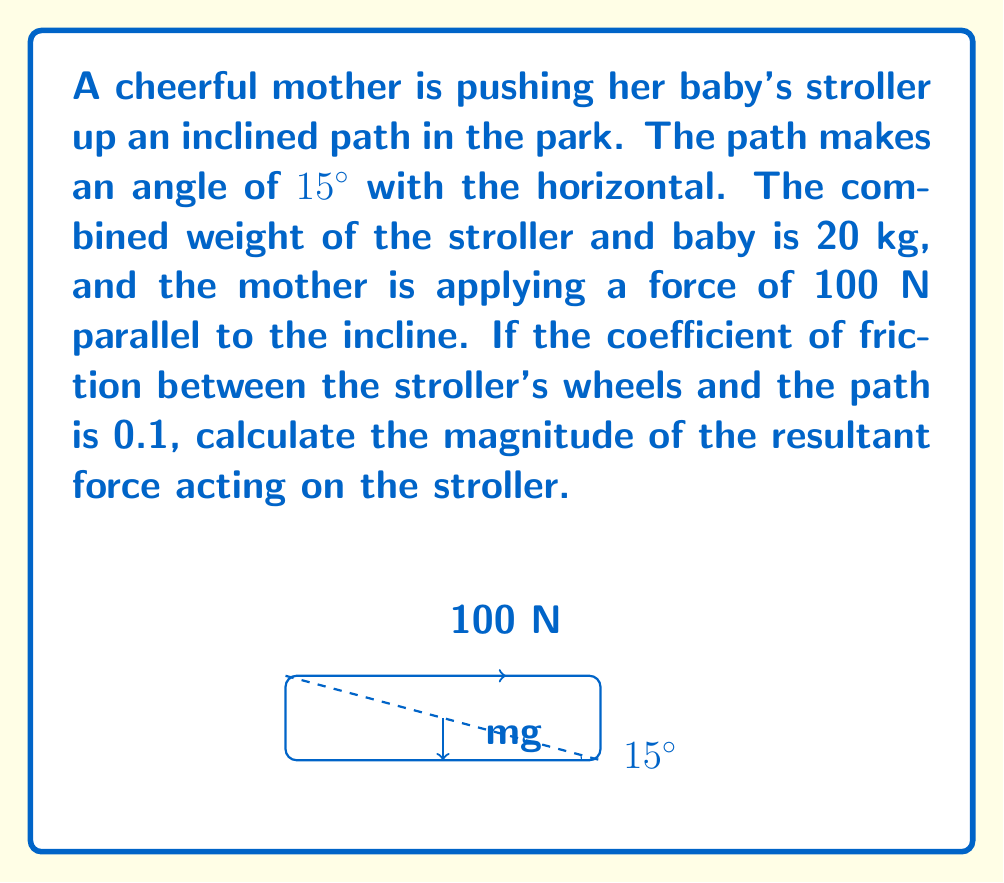Give your solution to this math problem. Let's break this problem down step-by-step:

1) First, we need to identify all forces acting on the stroller:
   - Weight (mg): $20 \text{ kg} \times 9.8 \text{ m/s}^2 = 196 \text{ N}$ (downward)
   - Normal force (N): perpendicular to the incline
   - Applied force (F): 100 N parallel to the incline
   - Friction force (f): opposite to the direction of motion

2) We need to resolve the weight into components parallel and perpendicular to the incline:
   - Weight parallel to incline: $mg \sin 15° = 196 \sin 15° = 50.73 \text{ N}$
   - Weight perpendicular to incline: $mg \cos 15° = 196 \cos 15° = 189.26 \text{ N}$

3) The normal force is equal to the component of weight perpendicular to the incline:
   $N = 189.26 \text{ N}$

4) Calculate the friction force:
   $f = \mu N = 0.1 \times 189.26 = 18.93 \text{ N}$

5) Now we can calculate the forces in the direction parallel to the incline:
   - Upward: Applied force = 100 N
   - Downward: Weight component + Friction = 50.73 N + 18.93 N = 69.66 N

6) The net force parallel to the incline:
   $F_{net} = 100 \text{ N} - 69.66 \text{ N} = 30.34 \text{ N}$

7) This net force is the resultant force acting on the stroller.
Answer: $30.34 \text{ N}$ 